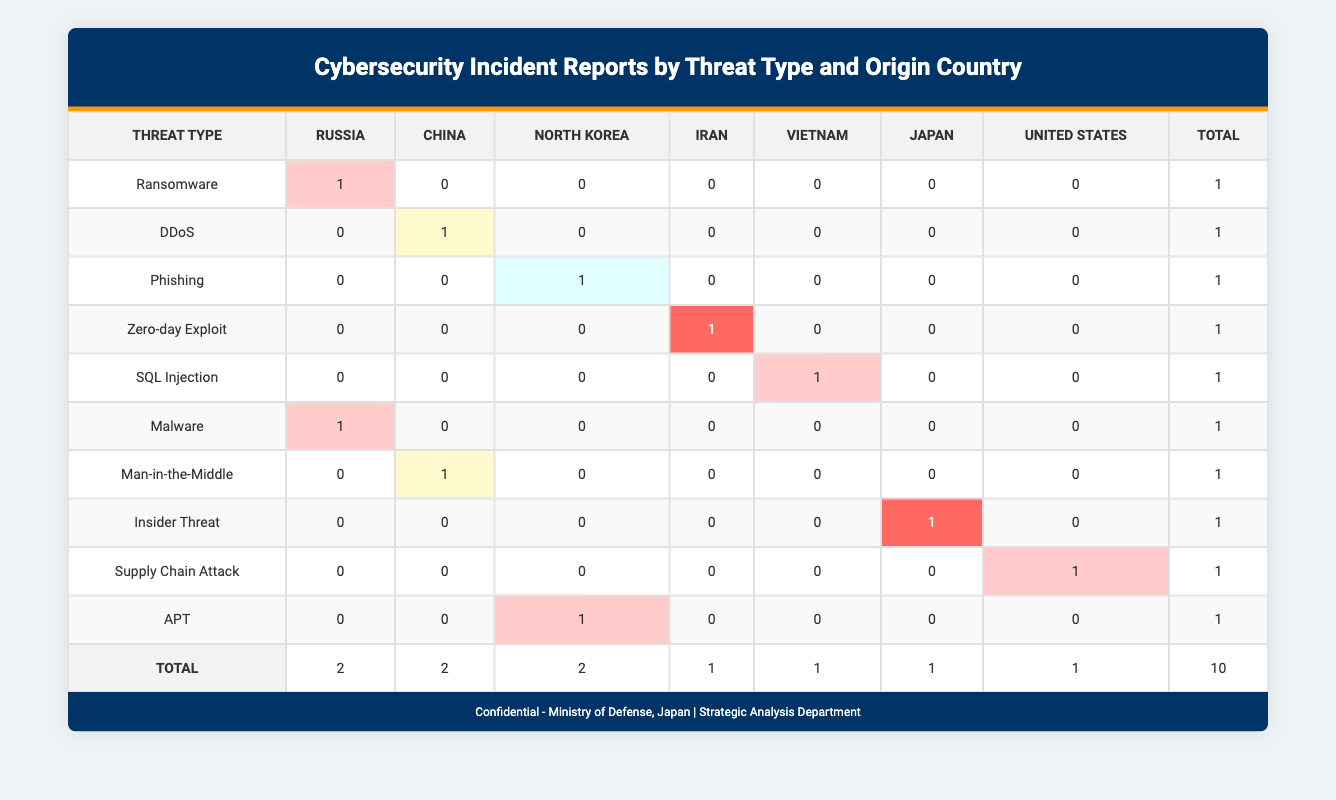What is the total number of cybersecurity incidents reported from Russia? In the table, there are two instances where the origin country is listed as Russia: one for Ransomware and one for Malware. Thus, we add these instances together: 1 + 1 = 2.
Answer: 2 Which threat type has the highest impact from North Korea? The incidents originating from North Korea include Phishing and APT. Among these, APT is categorized with a high impact while Phishing is categorized with a low impact. Therefore, APT, which has a high impact, is the one with the highest impact.
Answer: APT What is the sum of incidents categorized as Medium impact? In the table, the incidents with Medium impact come from China (DDoS and Man-in-the-Middle), making a total of two incidents under this category. Thus, we add them up: 1 + 1 = 2.
Answer: 2 Is there any cybersecurity incident reported from the United States? By looking at the table, there is one incident reported from the United States, which is categorized as a Supply Chain Attack. Hence, the answer to the question is yes.
Answer: Yes What threat types have been reported from China and what is their impact? The incidents from China include DDoS and Man-in-the-Middle. Both are categorized as Medium impact. Therefore, the threat types are DDoS and Man-in-the-Middle, both having Medium impact.
Answer: DDoS and Man-in-the-Middle, Medium impact How many total incidents were reported by Japan? According to the table, there is one incident from Japan categorized as an Insider Threat. Thus, the total number of incidents reported by Japan is 1.
Answer: 1 What percentage of incidents were classified as High impact? From the table, there are 4 incidents classified as High impact (Ransomware, SQL Injection, Malware, and APT) out of a total of 10 incidents. To find the percentage, we calculate (4 incidents / 10 total incidents) * 100 = 40%.
Answer: 40% Which country has reported the least number of incidents? Upon reviewing the total counts by country, Vietnam and Iran both have 1 incident each, while others have more. As such, both Vietnam and Iran reported the least number of incidents.
Answer: Vietnam and Iran What is the total number of incidents categorized as Critical impact? The table shows that there are two incidents categorized as Critical impact from Iran and Japan (Zero-day Exploit and Insider Threat). Therefore, we sum these critical incidents: 1 + 1 = 2.
Answer: 2 